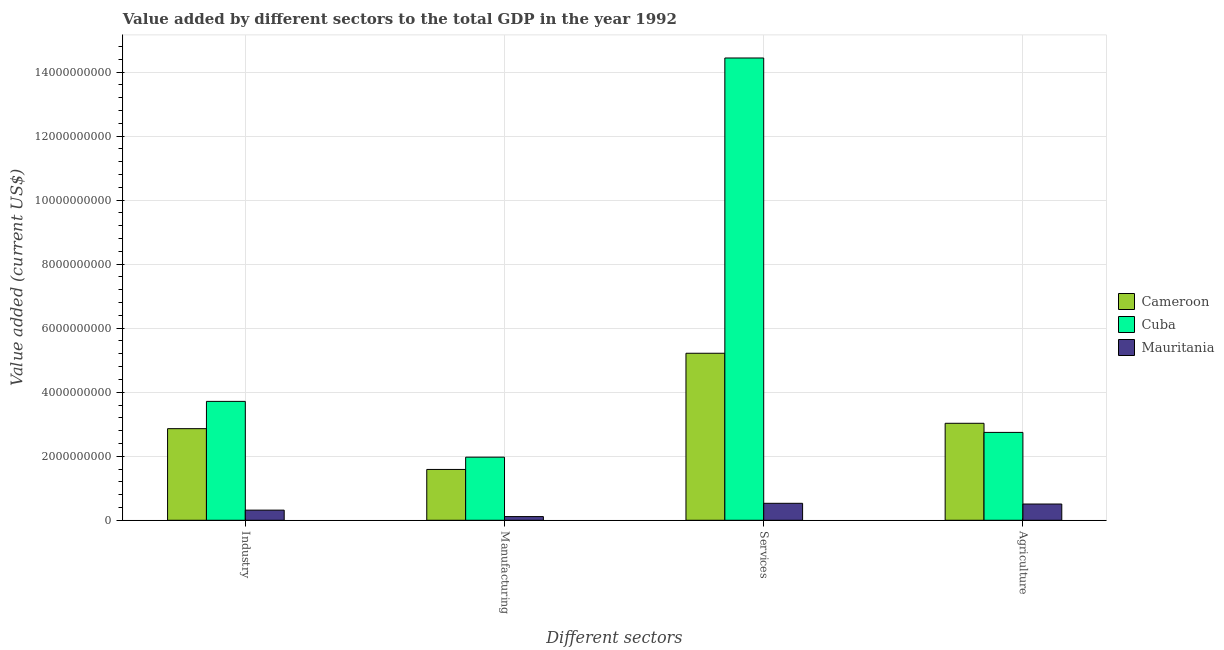How many different coloured bars are there?
Give a very brief answer. 3. How many bars are there on the 4th tick from the left?
Provide a short and direct response. 3. What is the label of the 1st group of bars from the left?
Your answer should be compact. Industry. What is the value added by agricultural sector in Mauritania?
Provide a short and direct response. 5.07e+08. Across all countries, what is the maximum value added by manufacturing sector?
Your answer should be very brief. 1.97e+09. Across all countries, what is the minimum value added by manufacturing sector?
Provide a short and direct response. 1.15e+08. In which country was the value added by services sector maximum?
Your answer should be very brief. Cuba. In which country was the value added by manufacturing sector minimum?
Offer a very short reply. Mauritania. What is the total value added by agricultural sector in the graph?
Provide a short and direct response. 6.28e+09. What is the difference between the value added by services sector in Cuba and that in Mauritania?
Ensure brevity in your answer.  1.39e+1. What is the difference between the value added by services sector in Cuba and the value added by manufacturing sector in Cameroon?
Your response must be concise. 1.29e+1. What is the average value added by services sector per country?
Keep it short and to the point. 6.73e+09. What is the difference between the value added by services sector and value added by agricultural sector in Cameroon?
Provide a succinct answer. 2.19e+09. What is the ratio of the value added by industrial sector in Cuba to that in Cameroon?
Offer a terse response. 1.3. Is the value added by manufacturing sector in Mauritania less than that in Cuba?
Provide a succinct answer. Yes. Is the difference between the value added by agricultural sector in Mauritania and Cuba greater than the difference between the value added by industrial sector in Mauritania and Cuba?
Offer a very short reply. Yes. What is the difference between the highest and the second highest value added by services sector?
Your answer should be very brief. 9.22e+09. What is the difference between the highest and the lowest value added by agricultural sector?
Give a very brief answer. 2.52e+09. In how many countries, is the value added by agricultural sector greater than the average value added by agricultural sector taken over all countries?
Provide a succinct answer. 2. Is the sum of the value added by manufacturing sector in Cameroon and Mauritania greater than the maximum value added by industrial sector across all countries?
Your answer should be very brief. No. What does the 2nd bar from the left in Industry represents?
Your response must be concise. Cuba. What does the 2nd bar from the right in Agriculture represents?
Your answer should be very brief. Cuba. Is it the case that in every country, the sum of the value added by industrial sector and value added by manufacturing sector is greater than the value added by services sector?
Provide a succinct answer. No. How many bars are there?
Provide a short and direct response. 12. How many countries are there in the graph?
Your answer should be very brief. 3. Are the values on the major ticks of Y-axis written in scientific E-notation?
Your answer should be very brief. No. Where does the legend appear in the graph?
Give a very brief answer. Center right. How many legend labels are there?
Keep it short and to the point. 3. How are the legend labels stacked?
Make the answer very short. Vertical. What is the title of the graph?
Your answer should be very brief. Value added by different sectors to the total GDP in the year 1992. What is the label or title of the X-axis?
Give a very brief answer. Different sectors. What is the label or title of the Y-axis?
Give a very brief answer. Value added (current US$). What is the Value added (current US$) of Cameroon in Industry?
Your answer should be very brief. 2.86e+09. What is the Value added (current US$) in Cuba in Industry?
Ensure brevity in your answer.  3.71e+09. What is the Value added (current US$) of Mauritania in Industry?
Offer a very short reply. 3.17e+08. What is the Value added (current US$) of Cameroon in Manufacturing?
Your answer should be very brief. 1.59e+09. What is the Value added (current US$) of Cuba in Manufacturing?
Offer a very short reply. 1.97e+09. What is the Value added (current US$) of Mauritania in Manufacturing?
Your response must be concise. 1.15e+08. What is the Value added (current US$) in Cameroon in Services?
Ensure brevity in your answer.  5.22e+09. What is the Value added (current US$) of Cuba in Services?
Your answer should be compact. 1.44e+1. What is the Value added (current US$) in Mauritania in Services?
Make the answer very short. 5.30e+08. What is the Value added (current US$) of Cameroon in Agriculture?
Your answer should be very brief. 3.03e+09. What is the Value added (current US$) of Cuba in Agriculture?
Provide a short and direct response. 2.74e+09. What is the Value added (current US$) of Mauritania in Agriculture?
Your response must be concise. 5.07e+08. Across all Different sectors, what is the maximum Value added (current US$) of Cameroon?
Offer a very short reply. 5.22e+09. Across all Different sectors, what is the maximum Value added (current US$) in Cuba?
Offer a terse response. 1.44e+1. Across all Different sectors, what is the maximum Value added (current US$) in Mauritania?
Offer a terse response. 5.30e+08. Across all Different sectors, what is the minimum Value added (current US$) of Cameroon?
Give a very brief answer. 1.59e+09. Across all Different sectors, what is the minimum Value added (current US$) in Cuba?
Keep it short and to the point. 1.97e+09. Across all Different sectors, what is the minimum Value added (current US$) of Mauritania?
Your response must be concise. 1.15e+08. What is the total Value added (current US$) of Cameroon in the graph?
Your answer should be compact. 1.27e+1. What is the total Value added (current US$) in Cuba in the graph?
Provide a succinct answer. 2.29e+1. What is the total Value added (current US$) in Mauritania in the graph?
Your answer should be very brief. 1.47e+09. What is the difference between the Value added (current US$) in Cameroon in Industry and that in Manufacturing?
Keep it short and to the point. 1.27e+09. What is the difference between the Value added (current US$) in Cuba in Industry and that in Manufacturing?
Your answer should be very brief. 1.74e+09. What is the difference between the Value added (current US$) of Mauritania in Industry and that in Manufacturing?
Provide a short and direct response. 2.02e+08. What is the difference between the Value added (current US$) in Cameroon in Industry and that in Services?
Offer a terse response. -2.36e+09. What is the difference between the Value added (current US$) of Cuba in Industry and that in Services?
Keep it short and to the point. -1.07e+1. What is the difference between the Value added (current US$) in Mauritania in Industry and that in Services?
Make the answer very short. -2.13e+08. What is the difference between the Value added (current US$) in Cameroon in Industry and that in Agriculture?
Provide a short and direct response. -1.68e+08. What is the difference between the Value added (current US$) in Cuba in Industry and that in Agriculture?
Your answer should be very brief. 9.69e+08. What is the difference between the Value added (current US$) of Mauritania in Industry and that in Agriculture?
Your response must be concise. -1.90e+08. What is the difference between the Value added (current US$) of Cameroon in Manufacturing and that in Services?
Make the answer very short. -3.63e+09. What is the difference between the Value added (current US$) in Cuba in Manufacturing and that in Services?
Offer a terse response. -1.25e+1. What is the difference between the Value added (current US$) in Mauritania in Manufacturing and that in Services?
Offer a very short reply. -4.15e+08. What is the difference between the Value added (current US$) in Cameroon in Manufacturing and that in Agriculture?
Make the answer very short. -1.44e+09. What is the difference between the Value added (current US$) of Cuba in Manufacturing and that in Agriculture?
Keep it short and to the point. -7.74e+08. What is the difference between the Value added (current US$) of Mauritania in Manufacturing and that in Agriculture?
Your response must be concise. -3.92e+08. What is the difference between the Value added (current US$) of Cameroon in Services and that in Agriculture?
Your answer should be compact. 2.19e+09. What is the difference between the Value added (current US$) in Cuba in Services and that in Agriculture?
Give a very brief answer. 1.17e+1. What is the difference between the Value added (current US$) in Mauritania in Services and that in Agriculture?
Give a very brief answer. 2.26e+07. What is the difference between the Value added (current US$) of Cameroon in Industry and the Value added (current US$) of Cuba in Manufacturing?
Your response must be concise. 8.91e+08. What is the difference between the Value added (current US$) in Cameroon in Industry and the Value added (current US$) in Mauritania in Manufacturing?
Your response must be concise. 2.75e+09. What is the difference between the Value added (current US$) of Cuba in Industry and the Value added (current US$) of Mauritania in Manufacturing?
Your response must be concise. 3.60e+09. What is the difference between the Value added (current US$) of Cameroon in Industry and the Value added (current US$) of Cuba in Services?
Offer a very short reply. -1.16e+1. What is the difference between the Value added (current US$) in Cameroon in Industry and the Value added (current US$) in Mauritania in Services?
Offer a terse response. 2.33e+09. What is the difference between the Value added (current US$) in Cuba in Industry and the Value added (current US$) in Mauritania in Services?
Offer a terse response. 3.18e+09. What is the difference between the Value added (current US$) of Cameroon in Industry and the Value added (current US$) of Cuba in Agriculture?
Provide a succinct answer. 1.17e+08. What is the difference between the Value added (current US$) of Cameroon in Industry and the Value added (current US$) of Mauritania in Agriculture?
Keep it short and to the point. 2.35e+09. What is the difference between the Value added (current US$) of Cuba in Industry and the Value added (current US$) of Mauritania in Agriculture?
Provide a short and direct response. 3.21e+09. What is the difference between the Value added (current US$) in Cameroon in Manufacturing and the Value added (current US$) in Cuba in Services?
Your answer should be compact. -1.29e+1. What is the difference between the Value added (current US$) in Cameroon in Manufacturing and the Value added (current US$) in Mauritania in Services?
Provide a succinct answer. 1.06e+09. What is the difference between the Value added (current US$) of Cuba in Manufacturing and the Value added (current US$) of Mauritania in Services?
Provide a short and direct response. 1.44e+09. What is the difference between the Value added (current US$) of Cameroon in Manufacturing and the Value added (current US$) of Cuba in Agriculture?
Your answer should be compact. -1.16e+09. What is the difference between the Value added (current US$) of Cameroon in Manufacturing and the Value added (current US$) of Mauritania in Agriculture?
Your answer should be compact. 1.08e+09. What is the difference between the Value added (current US$) in Cuba in Manufacturing and the Value added (current US$) in Mauritania in Agriculture?
Your answer should be compact. 1.46e+09. What is the difference between the Value added (current US$) in Cameroon in Services and the Value added (current US$) in Cuba in Agriculture?
Keep it short and to the point. 2.47e+09. What is the difference between the Value added (current US$) in Cameroon in Services and the Value added (current US$) in Mauritania in Agriculture?
Your response must be concise. 4.71e+09. What is the difference between the Value added (current US$) in Cuba in Services and the Value added (current US$) in Mauritania in Agriculture?
Offer a terse response. 1.39e+1. What is the average Value added (current US$) in Cameroon per Different sectors?
Provide a succinct answer. 3.17e+09. What is the average Value added (current US$) of Cuba per Different sectors?
Ensure brevity in your answer.  5.72e+09. What is the average Value added (current US$) of Mauritania per Different sectors?
Offer a very short reply. 3.67e+08. What is the difference between the Value added (current US$) in Cameroon and Value added (current US$) in Cuba in Industry?
Ensure brevity in your answer.  -8.52e+08. What is the difference between the Value added (current US$) in Cameroon and Value added (current US$) in Mauritania in Industry?
Your answer should be compact. 2.54e+09. What is the difference between the Value added (current US$) in Cuba and Value added (current US$) in Mauritania in Industry?
Your answer should be very brief. 3.40e+09. What is the difference between the Value added (current US$) in Cameroon and Value added (current US$) in Cuba in Manufacturing?
Offer a terse response. -3.83e+08. What is the difference between the Value added (current US$) of Cameroon and Value added (current US$) of Mauritania in Manufacturing?
Provide a short and direct response. 1.47e+09. What is the difference between the Value added (current US$) of Cuba and Value added (current US$) of Mauritania in Manufacturing?
Keep it short and to the point. 1.86e+09. What is the difference between the Value added (current US$) in Cameroon and Value added (current US$) in Cuba in Services?
Keep it short and to the point. -9.22e+09. What is the difference between the Value added (current US$) in Cameroon and Value added (current US$) in Mauritania in Services?
Ensure brevity in your answer.  4.69e+09. What is the difference between the Value added (current US$) in Cuba and Value added (current US$) in Mauritania in Services?
Make the answer very short. 1.39e+1. What is the difference between the Value added (current US$) of Cameroon and Value added (current US$) of Cuba in Agriculture?
Make the answer very short. 2.85e+08. What is the difference between the Value added (current US$) in Cameroon and Value added (current US$) in Mauritania in Agriculture?
Make the answer very short. 2.52e+09. What is the difference between the Value added (current US$) of Cuba and Value added (current US$) of Mauritania in Agriculture?
Ensure brevity in your answer.  2.24e+09. What is the ratio of the Value added (current US$) in Cameroon in Industry to that in Manufacturing?
Provide a short and direct response. 1.8. What is the ratio of the Value added (current US$) in Cuba in Industry to that in Manufacturing?
Give a very brief answer. 1.88. What is the ratio of the Value added (current US$) of Mauritania in Industry to that in Manufacturing?
Provide a succinct answer. 2.76. What is the ratio of the Value added (current US$) of Cameroon in Industry to that in Services?
Provide a succinct answer. 0.55. What is the ratio of the Value added (current US$) in Cuba in Industry to that in Services?
Your response must be concise. 0.26. What is the ratio of the Value added (current US$) in Mauritania in Industry to that in Services?
Ensure brevity in your answer.  0.6. What is the ratio of the Value added (current US$) of Cameroon in Industry to that in Agriculture?
Your answer should be very brief. 0.94. What is the ratio of the Value added (current US$) of Cuba in Industry to that in Agriculture?
Your response must be concise. 1.35. What is the ratio of the Value added (current US$) in Mauritania in Industry to that in Agriculture?
Provide a succinct answer. 0.62. What is the ratio of the Value added (current US$) of Cameroon in Manufacturing to that in Services?
Provide a succinct answer. 0.3. What is the ratio of the Value added (current US$) of Cuba in Manufacturing to that in Services?
Your answer should be compact. 0.14. What is the ratio of the Value added (current US$) in Mauritania in Manufacturing to that in Services?
Offer a very short reply. 0.22. What is the ratio of the Value added (current US$) in Cameroon in Manufacturing to that in Agriculture?
Make the answer very short. 0.52. What is the ratio of the Value added (current US$) of Cuba in Manufacturing to that in Agriculture?
Keep it short and to the point. 0.72. What is the ratio of the Value added (current US$) of Mauritania in Manufacturing to that in Agriculture?
Make the answer very short. 0.23. What is the ratio of the Value added (current US$) in Cameroon in Services to that in Agriculture?
Offer a very short reply. 1.72. What is the ratio of the Value added (current US$) of Cuba in Services to that in Agriculture?
Offer a terse response. 5.26. What is the ratio of the Value added (current US$) of Mauritania in Services to that in Agriculture?
Provide a succinct answer. 1.04. What is the difference between the highest and the second highest Value added (current US$) of Cameroon?
Give a very brief answer. 2.19e+09. What is the difference between the highest and the second highest Value added (current US$) of Cuba?
Offer a very short reply. 1.07e+1. What is the difference between the highest and the second highest Value added (current US$) of Mauritania?
Your response must be concise. 2.26e+07. What is the difference between the highest and the lowest Value added (current US$) of Cameroon?
Offer a very short reply. 3.63e+09. What is the difference between the highest and the lowest Value added (current US$) in Cuba?
Offer a terse response. 1.25e+1. What is the difference between the highest and the lowest Value added (current US$) in Mauritania?
Provide a succinct answer. 4.15e+08. 